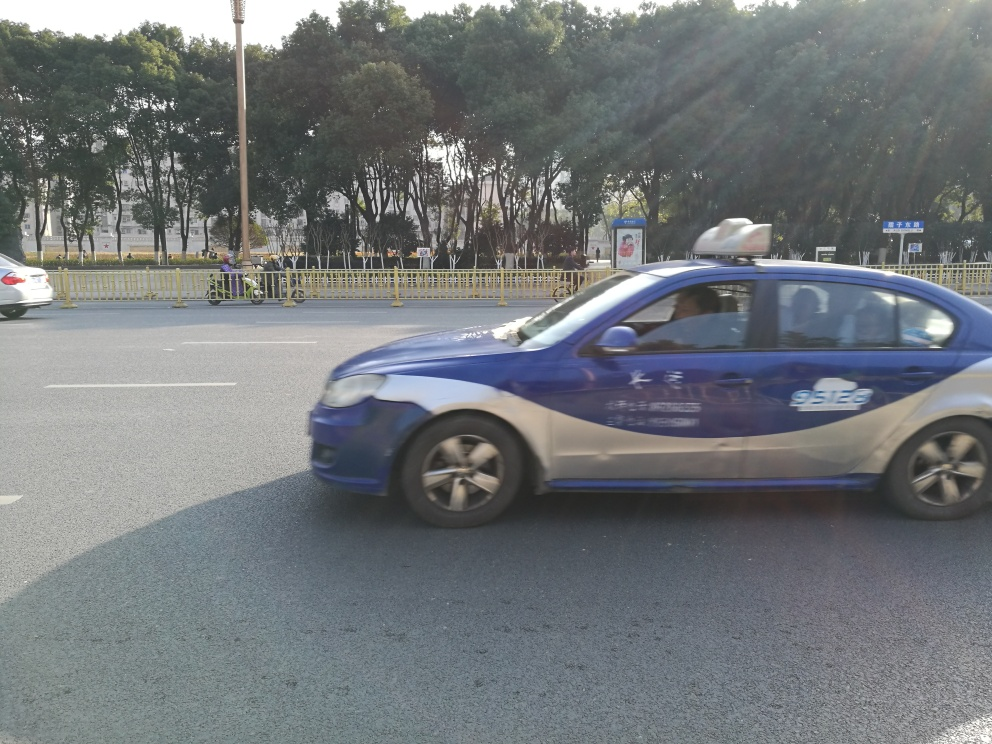What might be the speed of the vehicle? Given the degree of motion blur on the vehicle, it seems to be moving at a moderate speed, likely adhering to typical city traffic speeds. 